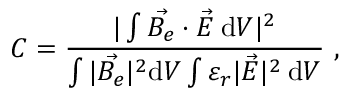Convert formula to latex. <formula><loc_0><loc_0><loc_500><loc_500>C = \frac { | \int \vec { B _ { e } } \cdot \vec { E } \, d V | ^ { 2 } } { \int | \vec { B _ { e } } | ^ { 2 } d V \int \varepsilon _ { r } | \vec { E } | ^ { 2 } \, d V } ,</formula> 